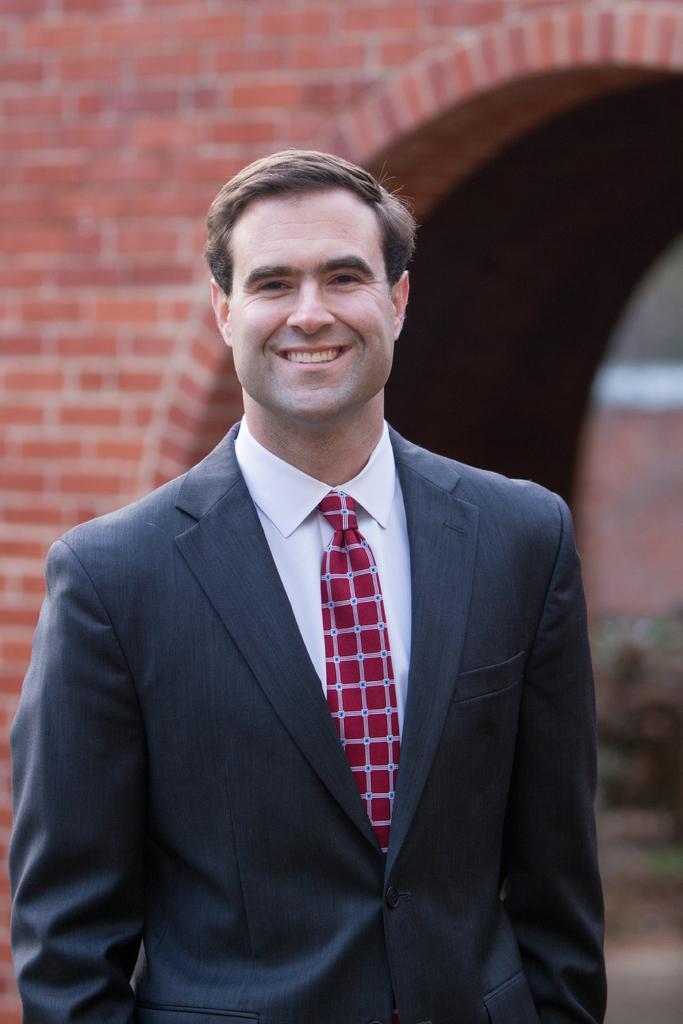In one or two sentences, can you explain what this image depicts? A person is standing and smiling wearing a suit. There is a brick wall at the back. 